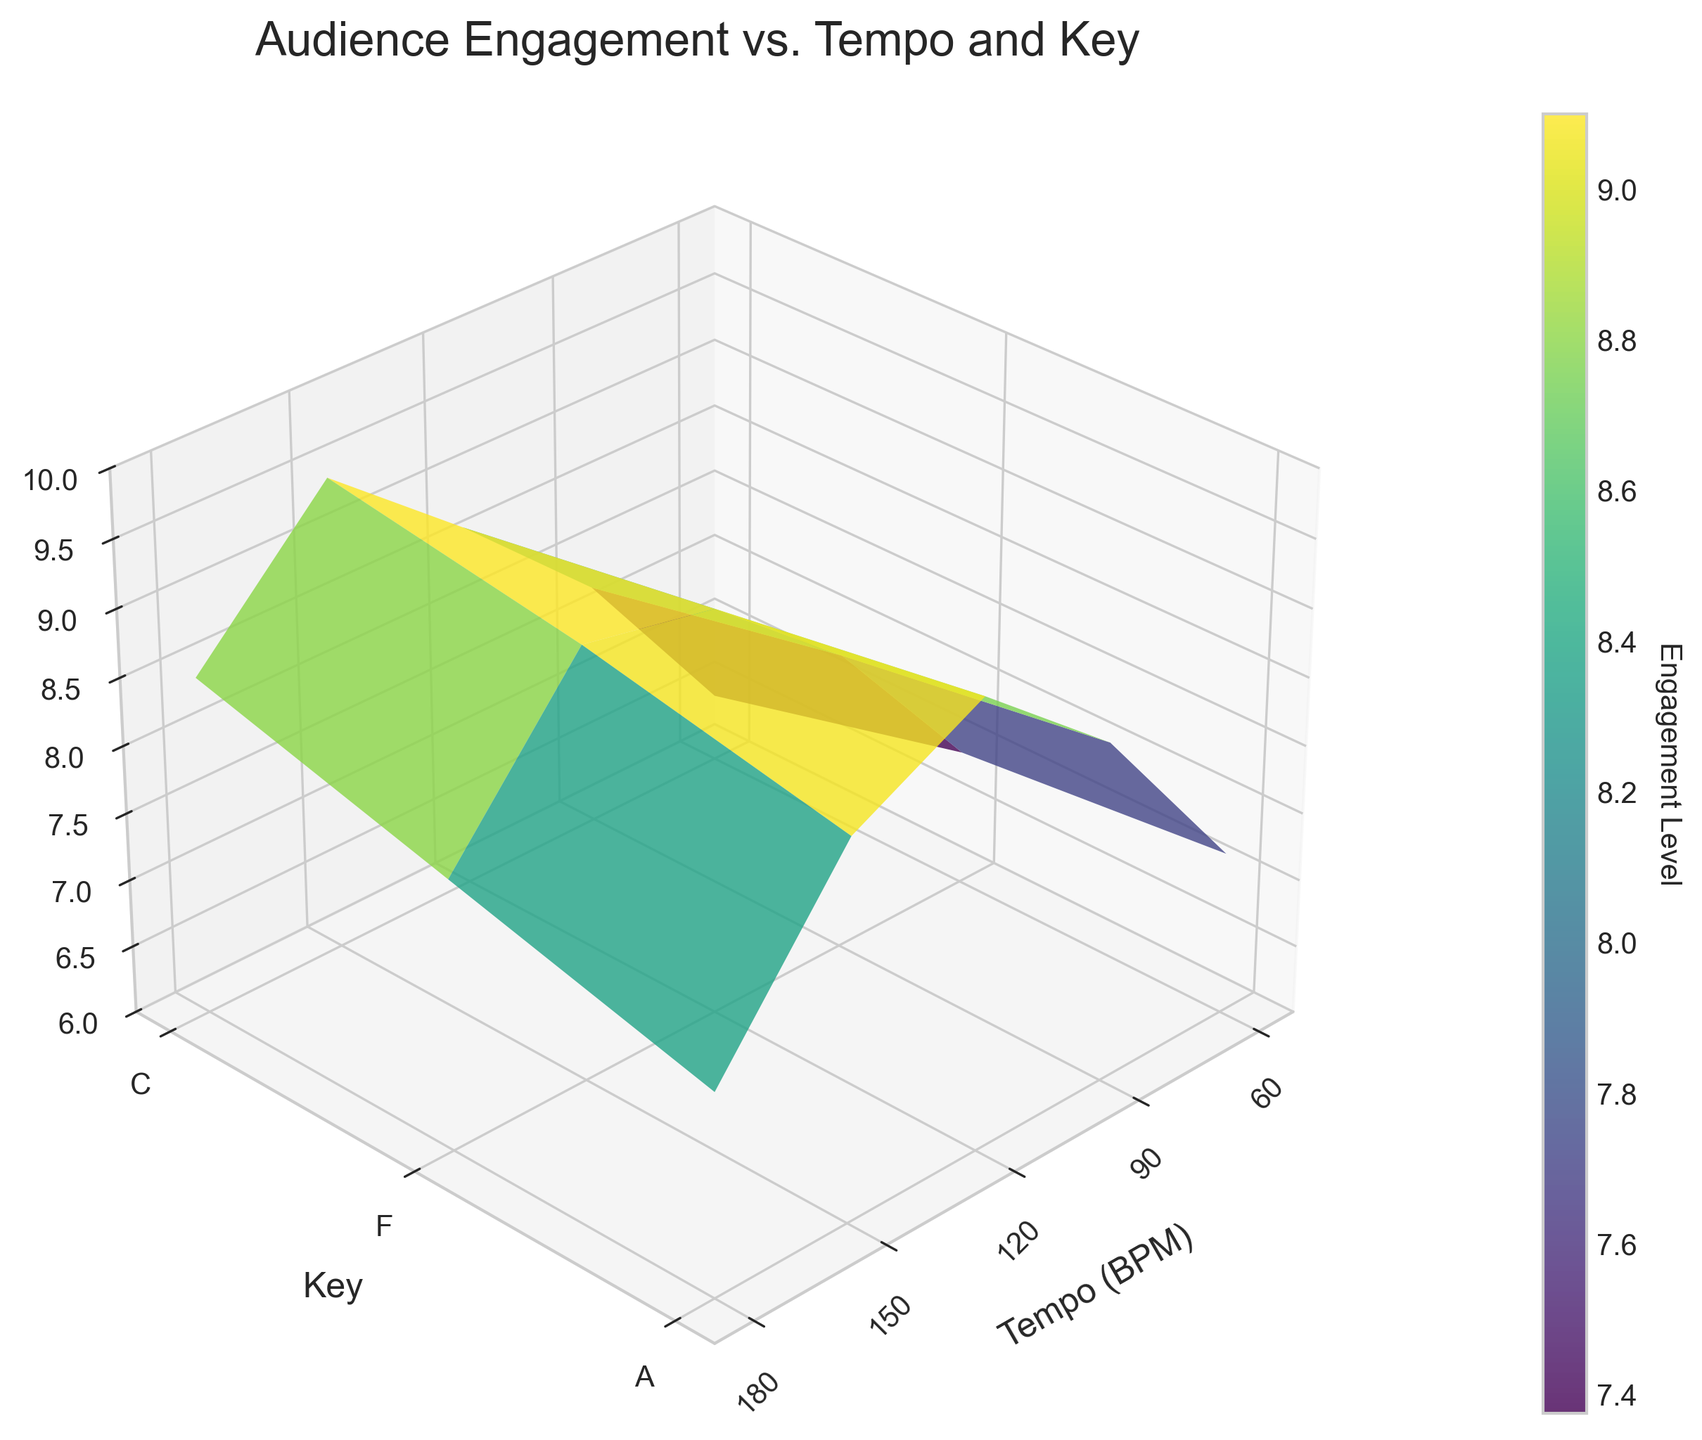What is the title of the plot? The title of the plot is usually written at the top center of the figure. Here, it states "Audience Engagement vs. Tempo and Key".
Answer: Audience Engagement vs. Tempo and Key What does the color bar on the right represent? The color bar beside the plot is labeled "Engagement Level" which indicates the value of Audience Engagement levels associated with different colors. The gradient shows the variation of engagement from low to high.
Answer: Engagement Level How does the engagement level change as tempo increases from 60 BPM to 180 BPM with the Key C? You can observe the engagement level by following the Key C trace on the surface. As tempo increases from 60 BPM to 180 BPM, the audience engagement first increases, reaching a peak at 150 BPM, and then decreases.
Answer: Peaks at 150 BPM then decreases Which Key generally shows the highest audience engagement across all tempos? By examining the surface plot, you notice that the key 'F' consistently displays higher audience engagement levels across nearly all the tempos compared to C and A.
Answer: F For which tempo and key does the audience engagement reach the highest value? Find the maximum z-value on the plot surface. The highest audience engagement level occurs at 150 BPM and Key C.
Answer: 150 BPM and Key C How does audience engagement change with increasing tempo for the key 'A'? Follow the surface along the key 'A'. As tempo increases from 60 BPM to 180 BPM, the engagement level first rises till 120 BPM, then decreases beyond 150 BPM.
Answer: Increases to 120 BPM, then decreases Describe the trend in audience engagement from 90 BPM to 120 BPM within each Key. From 90 BPM to 120 BPM, in all keys (C, F, A), the audience engagement shows a general increasing trend.
Answer: Increasing What is the range of audience engagement levels shown in the plot? By looking at the z-axis, the audience engagement levels range from 6 to 10.
Answer: 6 to 10 At 150 BPM, which key shows the least audience engagement? Observe the z-values for each key at 150 BPM. Key A has the lowest engagement level compared to C and F.
Answer: A Which key shows the most significant drop in engagement level from 150 BPM to 180 BPM? Compare the z-values for each key between 150 BPM and 180 BPM. Key A shows the most significant drop in engagement level.
Answer: A 